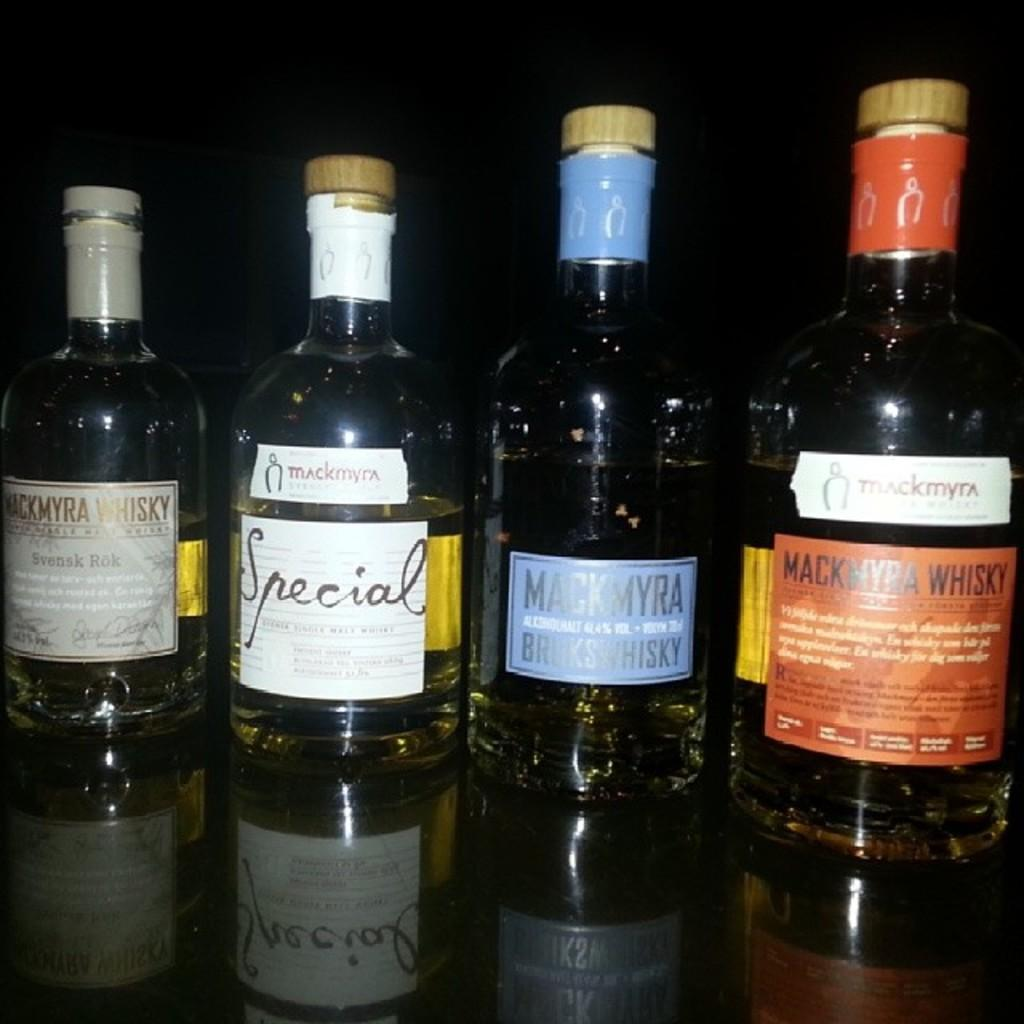<image>
Present a compact description of the photo's key features. a few wine bottles and one that had special written on it 